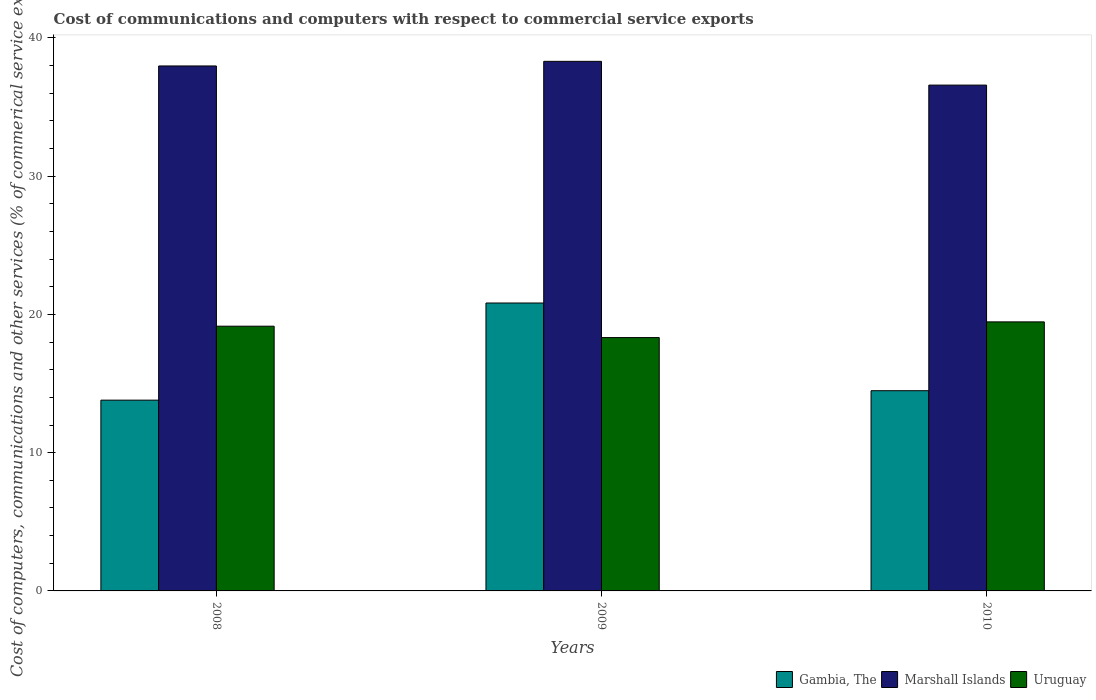How many different coloured bars are there?
Keep it short and to the point. 3. How many groups of bars are there?
Your answer should be compact. 3. In how many cases, is the number of bars for a given year not equal to the number of legend labels?
Make the answer very short. 0. What is the cost of communications and computers in Gambia, The in 2009?
Ensure brevity in your answer.  20.83. Across all years, what is the maximum cost of communications and computers in Gambia, The?
Provide a succinct answer. 20.83. Across all years, what is the minimum cost of communications and computers in Marshall Islands?
Offer a very short reply. 36.59. In which year was the cost of communications and computers in Gambia, The maximum?
Your answer should be very brief. 2009. What is the total cost of communications and computers in Uruguay in the graph?
Give a very brief answer. 56.94. What is the difference between the cost of communications and computers in Marshall Islands in 2009 and that in 2010?
Offer a very short reply. 1.72. What is the difference between the cost of communications and computers in Uruguay in 2010 and the cost of communications and computers in Gambia, The in 2009?
Make the answer very short. -1.36. What is the average cost of communications and computers in Gambia, The per year?
Offer a very short reply. 16.37. In the year 2010, what is the difference between the cost of communications and computers in Marshall Islands and cost of communications and computers in Gambia, The?
Ensure brevity in your answer.  22.11. What is the ratio of the cost of communications and computers in Gambia, The in 2008 to that in 2010?
Keep it short and to the point. 0.95. What is the difference between the highest and the second highest cost of communications and computers in Marshall Islands?
Offer a very short reply. 0.33. What is the difference between the highest and the lowest cost of communications and computers in Marshall Islands?
Ensure brevity in your answer.  1.72. What does the 1st bar from the left in 2010 represents?
Provide a short and direct response. Gambia, The. What does the 2nd bar from the right in 2010 represents?
Make the answer very short. Marshall Islands. How many bars are there?
Make the answer very short. 9. How many years are there in the graph?
Make the answer very short. 3. What is the difference between two consecutive major ticks on the Y-axis?
Ensure brevity in your answer.  10. Does the graph contain any zero values?
Your response must be concise. No. Does the graph contain grids?
Offer a terse response. No. Where does the legend appear in the graph?
Your answer should be very brief. Bottom right. How many legend labels are there?
Your response must be concise. 3. What is the title of the graph?
Your response must be concise. Cost of communications and computers with respect to commercial service exports. Does "Israel" appear as one of the legend labels in the graph?
Make the answer very short. No. What is the label or title of the X-axis?
Offer a very short reply. Years. What is the label or title of the Y-axis?
Your answer should be very brief. Cost of computers, communications and other services (% of commerical service exports). What is the Cost of computers, communications and other services (% of commerical service exports) of Gambia, The in 2008?
Give a very brief answer. 13.8. What is the Cost of computers, communications and other services (% of commerical service exports) of Marshall Islands in 2008?
Provide a succinct answer. 37.97. What is the Cost of computers, communications and other services (% of commerical service exports) in Uruguay in 2008?
Your answer should be compact. 19.15. What is the Cost of computers, communications and other services (% of commerical service exports) of Gambia, The in 2009?
Your answer should be compact. 20.83. What is the Cost of computers, communications and other services (% of commerical service exports) of Marshall Islands in 2009?
Offer a very short reply. 38.31. What is the Cost of computers, communications and other services (% of commerical service exports) in Uruguay in 2009?
Offer a very short reply. 18.33. What is the Cost of computers, communications and other services (% of commerical service exports) in Gambia, The in 2010?
Offer a very short reply. 14.48. What is the Cost of computers, communications and other services (% of commerical service exports) of Marshall Islands in 2010?
Offer a terse response. 36.59. What is the Cost of computers, communications and other services (% of commerical service exports) of Uruguay in 2010?
Make the answer very short. 19.46. Across all years, what is the maximum Cost of computers, communications and other services (% of commerical service exports) of Gambia, The?
Keep it short and to the point. 20.83. Across all years, what is the maximum Cost of computers, communications and other services (% of commerical service exports) of Marshall Islands?
Your answer should be very brief. 38.31. Across all years, what is the maximum Cost of computers, communications and other services (% of commerical service exports) of Uruguay?
Give a very brief answer. 19.46. Across all years, what is the minimum Cost of computers, communications and other services (% of commerical service exports) of Gambia, The?
Your answer should be very brief. 13.8. Across all years, what is the minimum Cost of computers, communications and other services (% of commerical service exports) in Marshall Islands?
Give a very brief answer. 36.59. Across all years, what is the minimum Cost of computers, communications and other services (% of commerical service exports) of Uruguay?
Keep it short and to the point. 18.33. What is the total Cost of computers, communications and other services (% of commerical service exports) of Gambia, The in the graph?
Ensure brevity in your answer.  49.11. What is the total Cost of computers, communications and other services (% of commerical service exports) in Marshall Islands in the graph?
Keep it short and to the point. 112.87. What is the total Cost of computers, communications and other services (% of commerical service exports) of Uruguay in the graph?
Keep it short and to the point. 56.94. What is the difference between the Cost of computers, communications and other services (% of commerical service exports) of Gambia, The in 2008 and that in 2009?
Your answer should be very brief. -7.03. What is the difference between the Cost of computers, communications and other services (% of commerical service exports) of Marshall Islands in 2008 and that in 2009?
Offer a very short reply. -0.33. What is the difference between the Cost of computers, communications and other services (% of commerical service exports) of Uruguay in 2008 and that in 2009?
Ensure brevity in your answer.  0.82. What is the difference between the Cost of computers, communications and other services (% of commerical service exports) in Gambia, The in 2008 and that in 2010?
Keep it short and to the point. -0.68. What is the difference between the Cost of computers, communications and other services (% of commerical service exports) of Marshall Islands in 2008 and that in 2010?
Your answer should be compact. 1.38. What is the difference between the Cost of computers, communications and other services (% of commerical service exports) in Uruguay in 2008 and that in 2010?
Your answer should be compact. -0.31. What is the difference between the Cost of computers, communications and other services (% of commerical service exports) of Gambia, The in 2009 and that in 2010?
Provide a short and direct response. 6.34. What is the difference between the Cost of computers, communications and other services (% of commerical service exports) of Marshall Islands in 2009 and that in 2010?
Keep it short and to the point. 1.72. What is the difference between the Cost of computers, communications and other services (% of commerical service exports) in Uruguay in 2009 and that in 2010?
Provide a succinct answer. -1.14. What is the difference between the Cost of computers, communications and other services (% of commerical service exports) in Gambia, The in 2008 and the Cost of computers, communications and other services (% of commerical service exports) in Marshall Islands in 2009?
Your answer should be very brief. -24.51. What is the difference between the Cost of computers, communications and other services (% of commerical service exports) of Gambia, The in 2008 and the Cost of computers, communications and other services (% of commerical service exports) of Uruguay in 2009?
Give a very brief answer. -4.53. What is the difference between the Cost of computers, communications and other services (% of commerical service exports) in Marshall Islands in 2008 and the Cost of computers, communications and other services (% of commerical service exports) in Uruguay in 2009?
Your answer should be very brief. 19.65. What is the difference between the Cost of computers, communications and other services (% of commerical service exports) in Gambia, The in 2008 and the Cost of computers, communications and other services (% of commerical service exports) in Marshall Islands in 2010?
Your answer should be compact. -22.79. What is the difference between the Cost of computers, communications and other services (% of commerical service exports) in Gambia, The in 2008 and the Cost of computers, communications and other services (% of commerical service exports) in Uruguay in 2010?
Give a very brief answer. -5.66. What is the difference between the Cost of computers, communications and other services (% of commerical service exports) of Marshall Islands in 2008 and the Cost of computers, communications and other services (% of commerical service exports) of Uruguay in 2010?
Keep it short and to the point. 18.51. What is the difference between the Cost of computers, communications and other services (% of commerical service exports) in Gambia, The in 2009 and the Cost of computers, communications and other services (% of commerical service exports) in Marshall Islands in 2010?
Your answer should be very brief. -15.76. What is the difference between the Cost of computers, communications and other services (% of commerical service exports) in Gambia, The in 2009 and the Cost of computers, communications and other services (% of commerical service exports) in Uruguay in 2010?
Keep it short and to the point. 1.36. What is the difference between the Cost of computers, communications and other services (% of commerical service exports) of Marshall Islands in 2009 and the Cost of computers, communications and other services (% of commerical service exports) of Uruguay in 2010?
Your answer should be very brief. 18.84. What is the average Cost of computers, communications and other services (% of commerical service exports) of Gambia, The per year?
Keep it short and to the point. 16.37. What is the average Cost of computers, communications and other services (% of commerical service exports) in Marshall Islands per year?
Ensure brevity in your answer.  37.62. What is the average Cost of computers, communications and other services (% of commerical service exports) of Uruguay per year?
Offer a terse response. 18.98. In the year 2008, what is the difference between the Cost of computers, communications and other services (% of commerical service exports) in Gambia, The and Cost of computers, communications and other services (% of commerical service exports) in Marshall Islands?
Offer a very short reply. -24.17. In the year 2008, what is the difference between the Cost of computers, communications and other services (% of commerical service exports) in Gambia, The and Cost of computers, communications and other services (% of commerical service exports) in Uruguay?
Your answer should be very brief. -5.35. In the year 2008, what is the difference between the Cost of computers, communications and other services (% of commerical service exports) in Marshall Islands and Cost of computers, communications and other services (% of commerical service exports) in Uruguay?
Provide a succinct answer. 18.82. In the year 2009, what is the difference between the Cost of computers, communications and other services (% of commerical service exports) of Gambia, The and Cost of computers, communications and other services (% of commerical service exports) of Marshall Islands?
Your answer should be compact. -17.48. In the year 2009, what is the difference between the Cost of computers, communications and other services (% of commerical service exports) of Gambia, The and Cost of computers, communications and other services (% of commerical service exports) of Uruguay?
Offer a very short reply. 2.5. In the year 2009, what is the difference between the Cost of computers, communications and other services (% of commerical service exports) in Marshall Islands and Cost of computers, communications and other services (% of commerical service exports) in Uruguay?
Provide a succinct answer. 19.98. In the year 2010, what is the difference between the Cost of computers, communications and other services (% of commerical service exports) in Gambia, The and Cost of computers, communications and other services (% of commerical service exports) in Marshall Islands?
Your response must be concise. -22.11. In the year 2010, what is the difference between the Cost of computers, communications and other services (% of commerical service exports) in Gambia, The and Cost of computers, communications and other services (% of commerical service exports) in Uruguay?
Ensure brevity in your answer.  -4.98. In the year 2010, what is the difference between the Cost of computers, communications and other services (% of commerical service exports) of Marshall Islands and Cost of computers, communications and other services (% of commerical service exports) of Uruguay?
Give a very brief answer. 17.13. What is the ratio of the Cost of computers, communications and other services (% of commerical service exports) of Gambia, The in 2008 to that in 2009?
Keep it short and to the point. 0.66. What is the ratio of the Cost of computers, communications and other services (% of commerical service exports) in Marshall Islands in 2008 to that in 2009?
Your answer should be compact. 0.99. What is the ratio of the Cost of computers, communications and other services (% of commerical service exports) in Uruguay in 2008 to that in 2009?
Keep it short and to the point. 1.04. What is the ratio of the Cost of computers, communications and other services (% of commerical service exports) in Gambia, The in 2008 to that in 2010?
Keep it short and to the point. 0.95. What is the ratio of the Cost of computers, communications and other services (% of commerical service exports) in Marshall Islands in 2008 to that in 2010?
Ensure brevity in your answer.  1.04. What is the ratio of the Cost of computers, communications and other services (% of commerical service exports) of Uruguay in 2008 to that in 2010?
Offer a very short reply. 0.98. What is the ratio of the Cost of computers, communications and other services (% of commerical service exports) of Gambia, The in 2009 to that in 2010?
Make the answer very short. 1.44. What is the ratio of the Cost of computers, communications and other services (% of commerical service exports) in Marshall Islands in 2009 to that in 2010?
Offer a terse response. 1.05. What is the ratio of the Cost of computers, communications and other services (% of commerical service exports) of Uruguay in 2009 to that in 2010?
Offer a terse response. 0.94. What is the difference between the highest and the second highest Cost of computers, communications and other services (% of commerical service exports) in Gambia, The?
Offer a very short reply. 6.34. What is the difference between the highest and the second highest Cost of computers, communications and other services (% of commerical service exports) of Marshall Islands?
Keep it short and to the point. 0.33. What is the difference between the highest and the second highest Cost of computers, communications and other services (% of commerical service exports) in Uruguay?
Your answer should be very brief. 0.31. What is the difference between the highest and the lowest Cost of computers, communications and other services (% of commerical service exports) in Gambia, The?
Keep it short and to the point. 7.03. What is the difference between the highest and the lowest Cost of computers, communications and other services (% of commerical service exports) of Marshall Islands?
Provide a succinct answer. 1.72. What is the difference between the highest and the lowest Cost of computers, communications and other services (% of commerical service exports) of Uruguay?
Offer a very short reply. 1.14. 